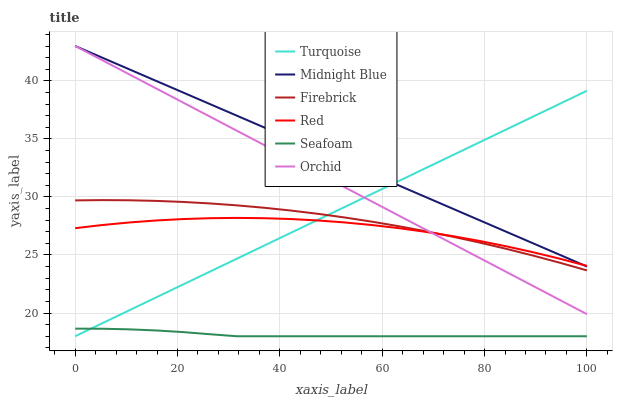Does Seafoam have the minimum area under the curve?
Answer yes or no. Yes. Does Midnight Blue have the maximum area under the curve?
Answer yes or no. Yes. Does Firebrick have the minimum area under the curve?
Answer yes or no. No. Does Firebrick have the maximum area under the curve?
Answer yes or no. No. Is Turquoise the smoothest?
Answer yes or no. Yes. Is Red the roughest?
Answer yes or no. Yes. Is Midnight Blue the smoothest?
Answer yes or no. No. Is Midnight Blue the roughest?
Answer yes or no. No. Does Midnight Blue have the lowest value?
Answer yes or no. No. Does Orchid have the highest value?
Answer yes or no. Yes. Does Firebrick have the highest value?
Answer yes or no. No. Is Seafoam less than Midnight Blue?
Answer yes or no. Yes. Is Firebrick greater than Seafoam?
Answer yes or no. Yes. Does Red intersect Firebrick?
Answer yes or no. Yes. Is Red less than Firebrick?
Answer yes or no. No. Is Red greater than Firebrick?
Answer yes or no. No. Does Seafoam intersect Midnight Blue?
Answer yes or no. No. 